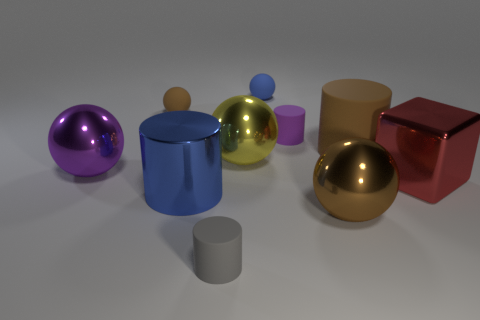Subtract all blue cylinders. How many cylinders are left? 3 Subtract 2 cylinders. How many cylinders are left? 2 Subtract all blue spheres. How many spheres are left? 4 Subtract all brown cylinders. Subtract all green spheres. How many cylinders are left? 3 Subtract all cylinders. How many objects are left? 6 Subtract all small purple rubber things. Subtract all large purple metallic things. How many objects are left? 8 Add 1 large yellow metallic objects. How many large yellow metallic objects are left? 2 Add 4 tiny gray matte cylinders. How many tiny gray matte cylinders exist? 5 Subtract 0 green cylinders. How many objects are left? 10 